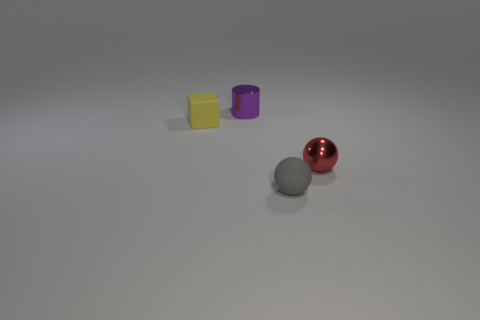Subtract all blue cylinders. Subtract all blue blocks. How many cylinders are left? 1 Add 1 red things. How many objects exist? 5 Subtract all cylinders. How many objects are left? 3 Subtract 1 yellow cubes. How many objects are left? 3 Subtract all gray balls. Subtract all cyan matte objects. How many objects are left? 3 Add 2 tiny rubber spheres. How many tiny rubber spheres are left? 3 Add 1 metallic cylinders. How many metallic cylinders exist? 2 